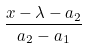<formula> <loc_0><loc_0><loc_500><loc_500>\frac { x - \lambda - a _ { 2 } } { a _ { 2 } - a _ { 1 } }</formula> 